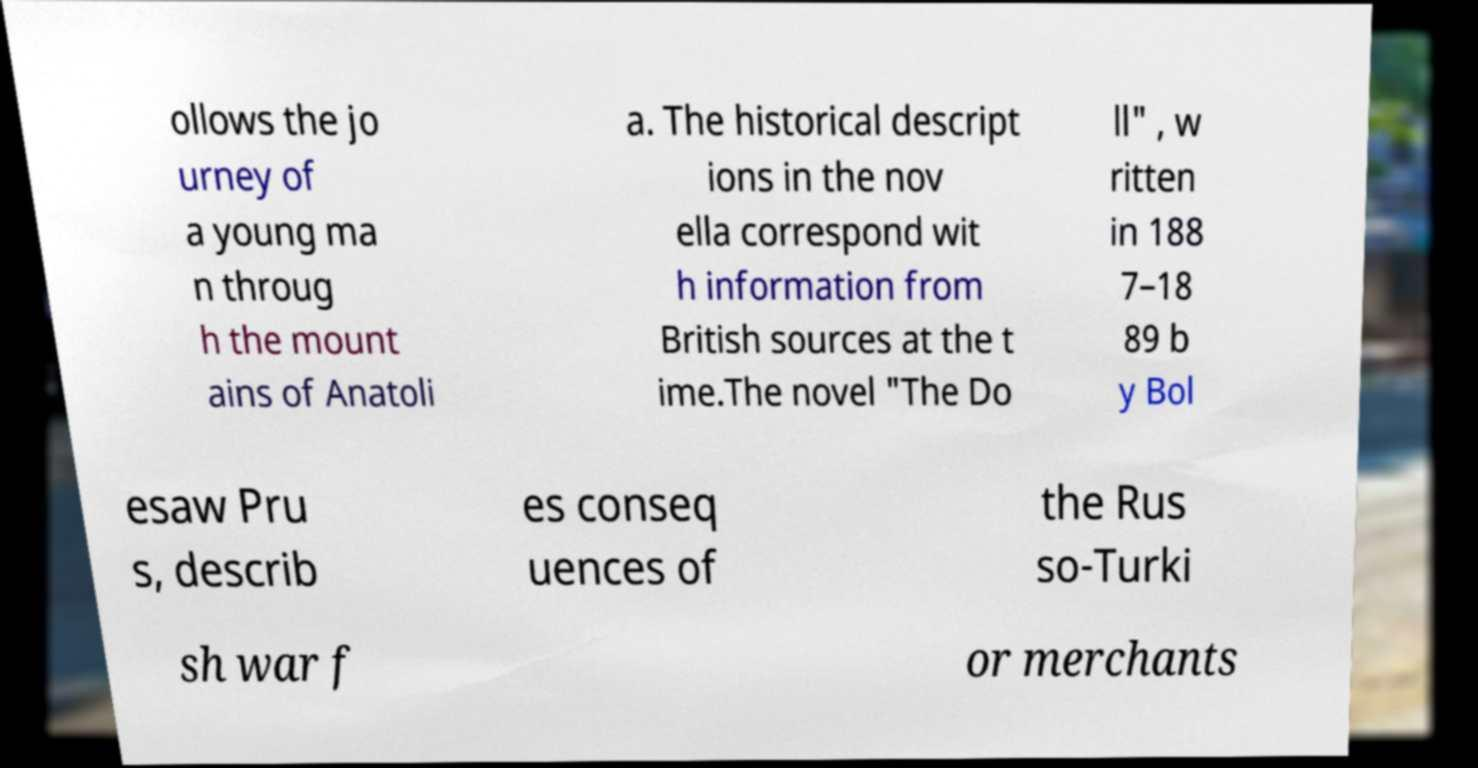I need the written content from this picture converted into text. Can you do that? ollows the jo urney of a young ma n throug h the mount ains of Anatoli a. The historical descript ions in the nov ella correspond wit h information from British sources at the t ime.The novel "The Do ll" , w ritten in 188 7–18 89 b y Bol esaw Pru s, describ es conseq uences of the Rus so-Turki sh war f or merchants 